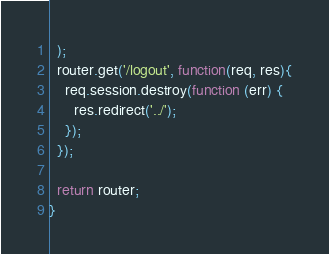Convert code to text. <code><loc_0><loc_0><loc_500><loc_500><_JavaScript_>  );
  router.get('/logout', function(req, res){
    req.session.destroy(function (err) {
      res.redirect('../');
    });
  });

  return router;
}
</code> 